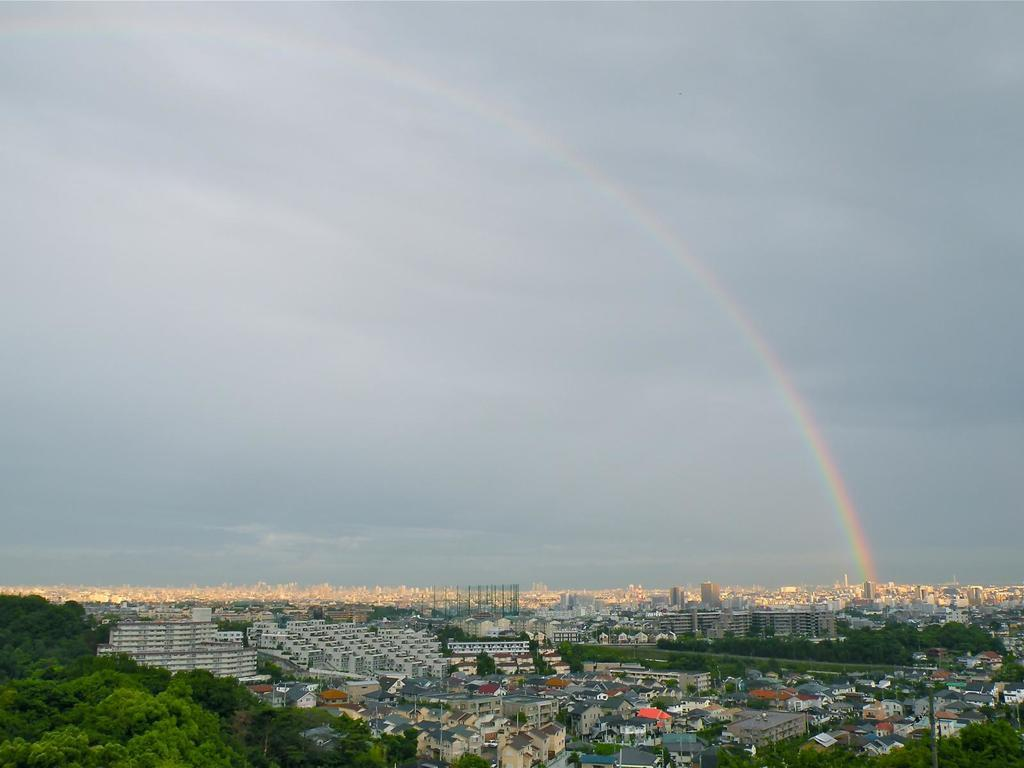What type of structures can be seen in the image? There are buildings in the image. What other natural elements are present in the image? There are trees in the image. What is visible at the top of the image? The sky is visible at the top of the image. What can be observed in the sky? There are clouds and a rainbow in the sky. What type of hair can be seen on the buildings in the image? There is no hair present on the buildings in the image. Are there any pets visible in the image? There are no pets visible in the image. 